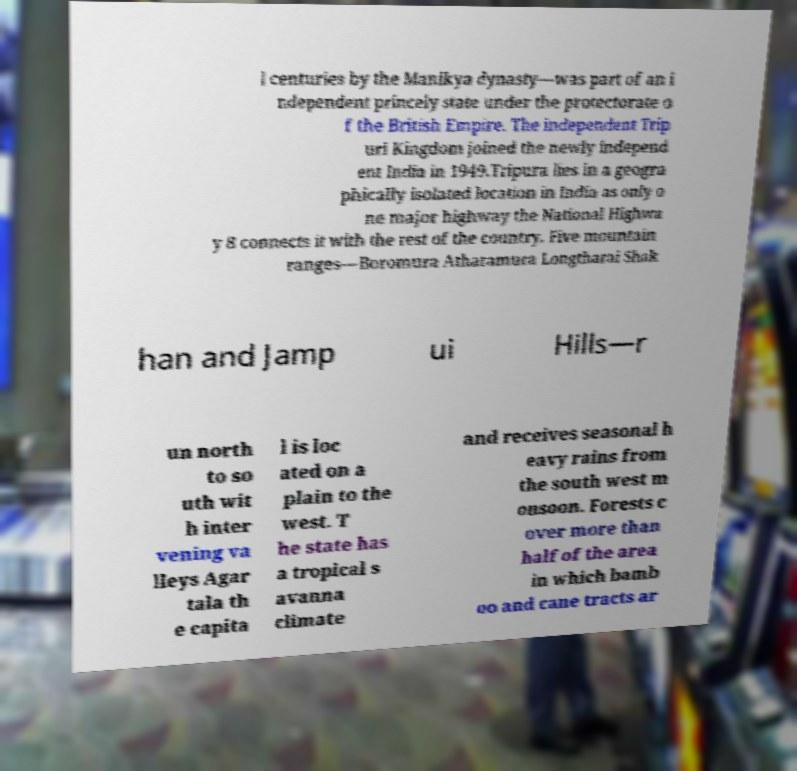Can you read and provide the text displayed in the image?This photo seems to have some interesting text. Can you extract and type it out for me? l centuries by the Manikya dynasty—was part of an i ndependent princely state under the protectorate o f the British Empire. The independent Trip uri Kingdom joined the newly independ ent India in 1949.Tripura lies in a geogra phically isolated location in India as only o ne major highway the National Highwa y 8 connects it with the rest of the country. Five mountain ranges—Boromura Atharamura Longtharai Shak han and Jamp ui Hills—r un north to so uth wit h inter vening va lleys Agar tala th e capita l is loc ated on a plain to the west. T he state has a tropical s avanna climate and receives seasonal h eavy rains from the south west m onsoon. Forests c over more than half of the area in which bamb oo and cane tracts ar 